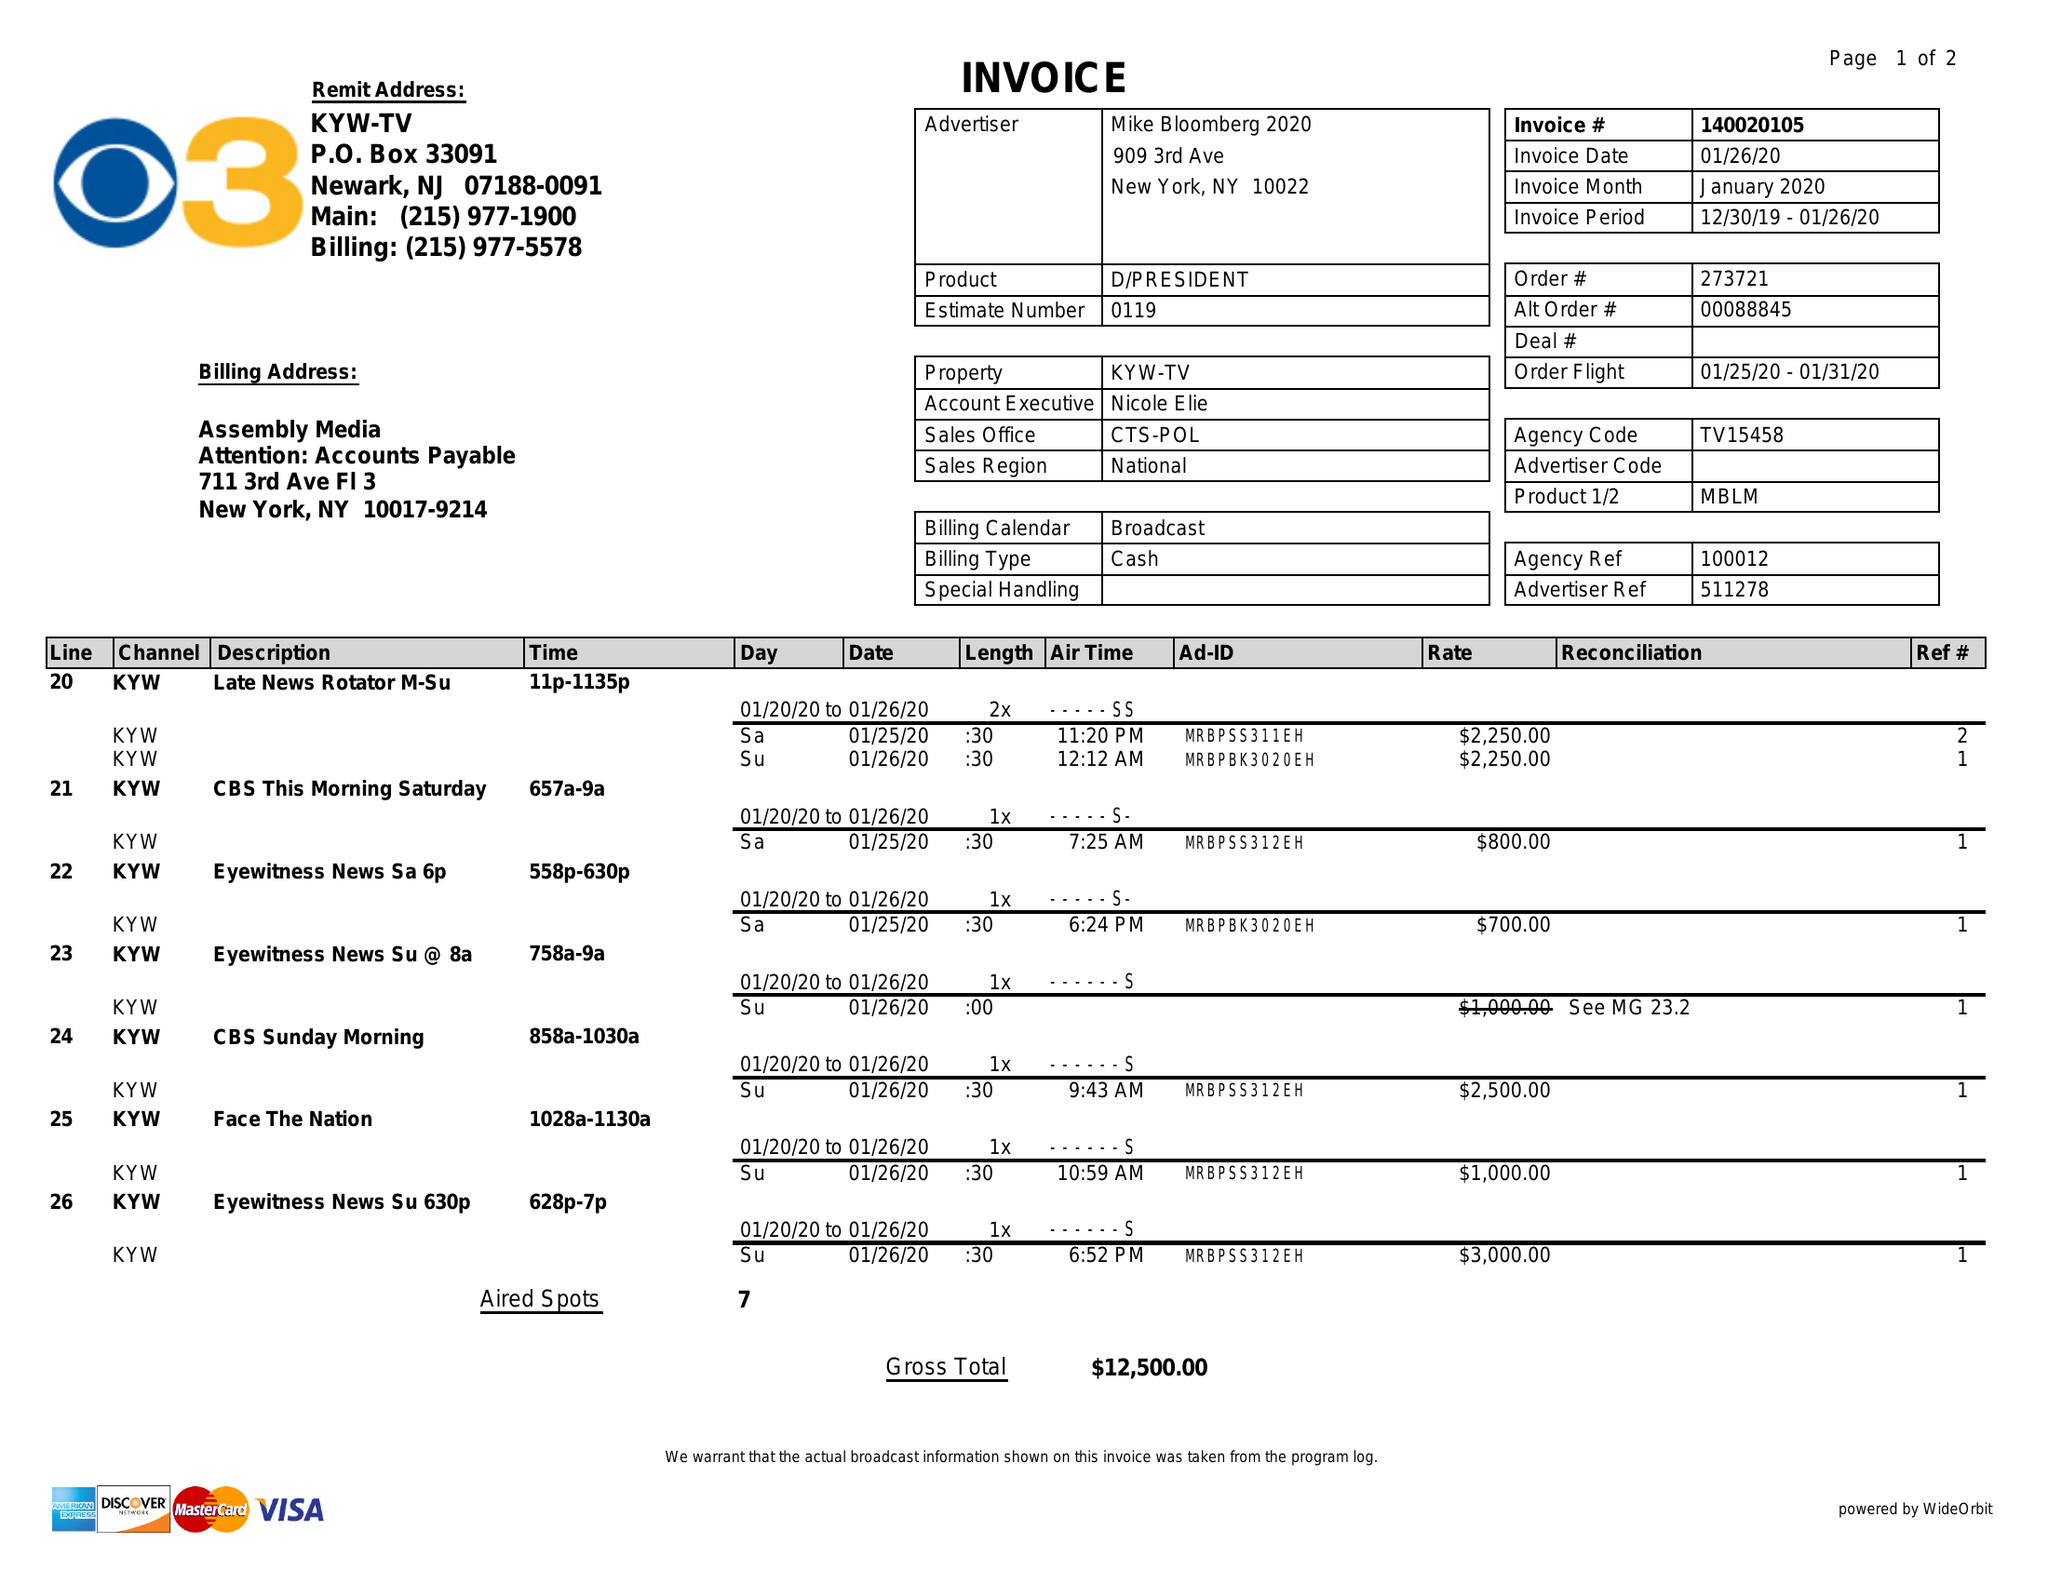What is the value for the flight_from?
Answer the question using a single word or phrase. 01/25/20 